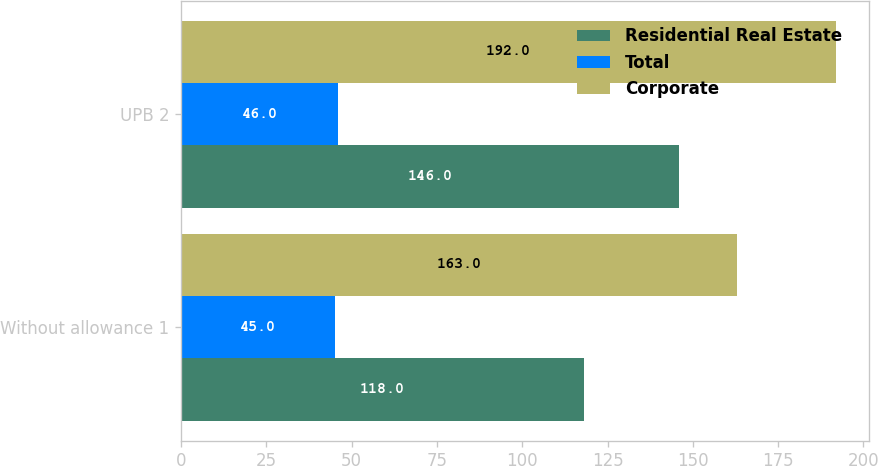Convert chart. <chart><loc_0><loc_0><loc_500><loc_500><stacked_bar_chart><ecel><fcel>Without allowance 1<fcel>UPB 2<nl><fcel>Residential Real Estate<fcel>118<fcel>146<nl><fcel>Total<fcel>45<fcel>46<nl><fcel>Corporate<fcel>163<fcel>192<nl></chart> 